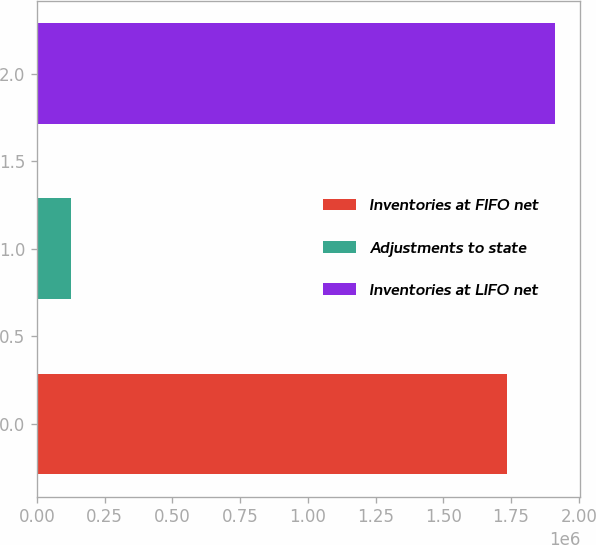Convert chart. <chart><loc_0><loc_0><loc_500><loc_500><bar_chart><fcel>Inventories at FIFO net<fcel>Adjustments to state<fcel>Inventories at LIFO net<nl><fcel>1.73706e+06<fcel>126811<fcel>1.91076e+06<nl></chart> 